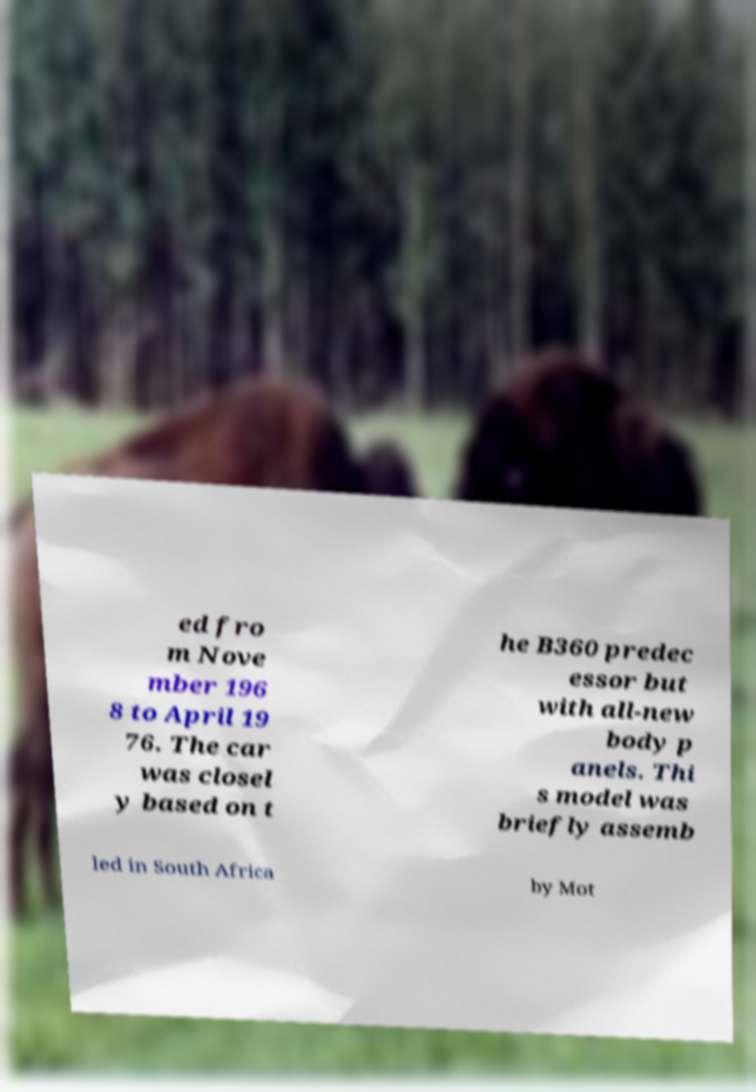Can you accurately transcribe the text from the provided image for me? ed fro m Nove mber 196 8 to April 19 76. The car was closel y based on t he B360 predec essor but with all-new body p anels. Thi s model was briefly assemb led in South Africa by Mot 